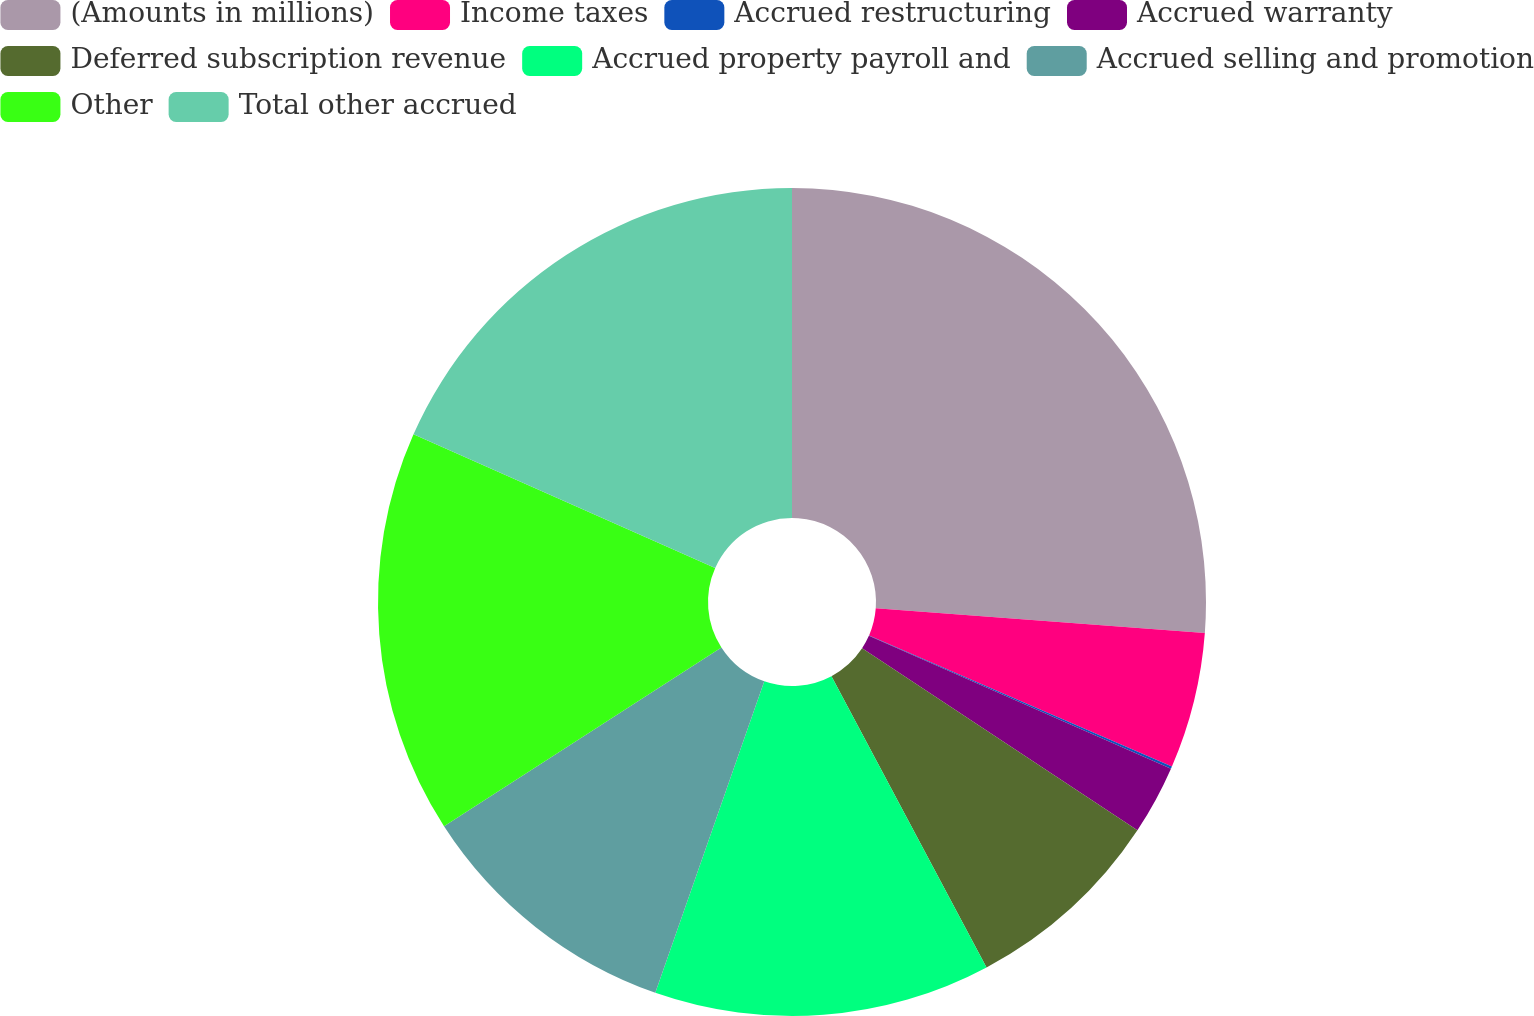Convert chart to OTSL. <chart><loc_0><loc_0><loc_500><loc_500><pie_chart><fcel>(Amounts in millions)<fcel>Income taxes<fcel>Accrued restructuring<fcel>Accrued warranty<fcel>Deferred subscription revenue<fcel>Accrued property payroll and<fcel>Accrued selling and promotion<fcel>Other<fcel>Total other accrued<nl><fcel>26.19%<fcel>5.31%<fcel>0.09%<fcel>2.7%<fcel>7.92%<fcel>13.14%<fcel>10.53%<fcel>15.75%<fcel>18.36%<nl></chart> 